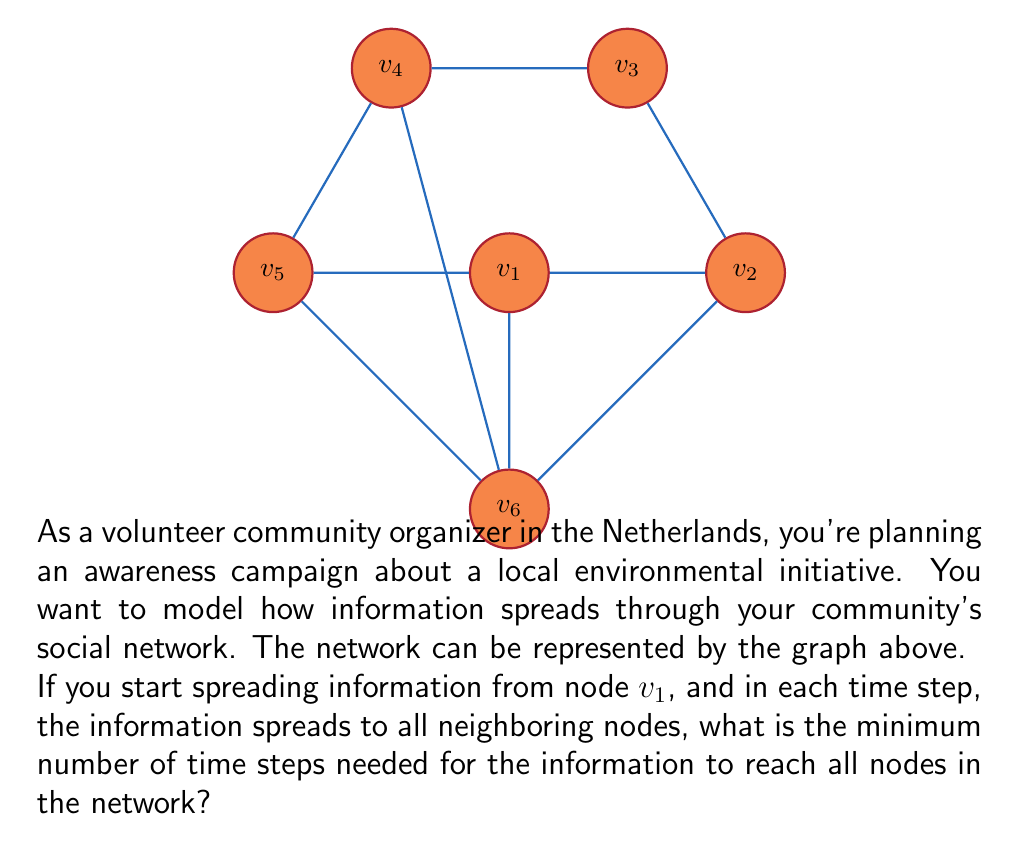Show me your answer to this math problem. To solve this problem, we need to analyze how the information spreads through the network step by step:

1) At the beginning (time step 0), only $v_1$ has the information.

2) After the first time step (t = 1):
   - The information spreads from $v_1$ to its direct neighbors: $v_2$, $v_5$, and $v_6$.
   - Nodes with information: $v_1$, $v_2$, $v_5$, $v_6$

3) After the second time step (t = 2):
   - The information spreads from $v_2$ to $v_3$
   - The information spreads from $v_5$ to $v_4$
   - Nodes with information: $v_1$, $v_2$, $v_3$, $v_4$, $v_5$, $v_6$

At this point, all nodes in the network have received the information.

This process can be described mathematically using the concept of graph distance. The minimum number of time steps needed is equal to the maximum graph distance (or eccentricity) from the starting node $v_1$ to any other node in the graph.

We can express this as:

$$\text{Minimum time steps} = \max_{v \in V} d(v_1, v)$$

where $d(v_1, v)$ is the shortest path distance from $v_1$ to node $v$, and $V$ is the set of all nodes in the graph.

In this case, the maximum distance from $v_1$ to any other node is 2, which occurs for nodes $v_3$ and $v_4$.
Answer: 2 time steps 